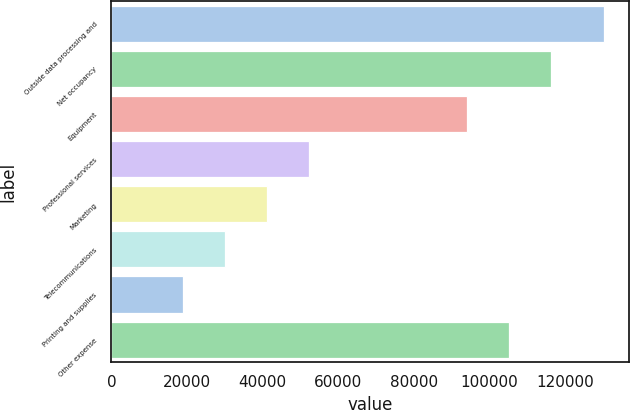Convert chart to OTSL. <chart><loc_0><loc_0><loc_500><loc_500><bar_chart><fcel>Outside data processing and<fcel>Net occupancy<fcel>Equipment<fcel>Professional services<fcel>Marketing<fcel>Telecommunications<fcel>Printing and supplies<fcel>Other expense<nl><fcel>130226<fcel>116236<fcel>93965<fcel>52276.8<fcel>41141.2<fcel>30005.6<fcel>18870<fcel>105101<nl></chart> 